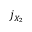<formula> <loc_0><loc_0><loc_500><loc_500>j _ { X _ { 2 } }</formula> 